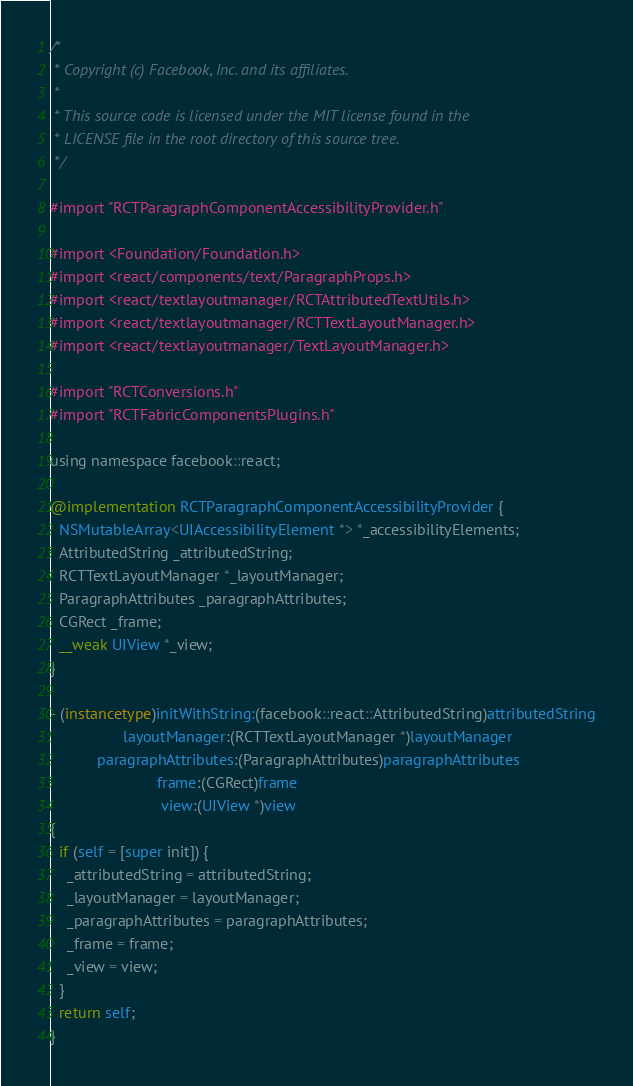Convert code to text. <code><loc_0><loc_0><loc_500><loc_500><_ObjectiveC_>/*
 * Copyright (c) Facebook, Inc. and its affiliates.
 *
 * This source code is licensed under the MIT license found in the
 * LICENSE file in the root directory of this source tree.
 */

#import "RCTParagraphComponentAccessibilityProvider.h"

#import <Foundation/Foundation.h>
#import <react/components/text/ParagraphProps.h>
#import <react/textlayoutmanager/RCTAttributedTextUtils.h>
#import <react/textlayoutmanager/RCTTextLayoutManager.h>
#import <react/textlayoutmanager/TextLayoutManager.h>

#import "RCTConversions.h"
#import "RCTFabricComponentsPlugins.h"

using namespace facebook::react;

@implementation RCTParagraphComponentAccessibilityProvider {
  NSMutableArray<UIAccessibilityElement *> *_accessibilityElements;
  AttributedString _attributedString;
  RCTTextLayoutManager *_layoutManager;
  ParagraphAttributes _paragraphAttributes;
  CGRect _frame;
  __weak UIView *_view;
}

- (instancetype)initWithString:(facebook::react::AttributedString)attributedString
                 layoutManager:(RCTTextLayoutManager *)layoutManager
           paragraphAttributes:(ParagraphAttributes)paragraphAttributes
                         frame:(CGRect)frame
                          view:(UIView *)view
{
  if (self = [super init]) {
    _attributedString = attributedString;
    _layoutManager = layoutManager;
    _paragraphAttributes = paragraphAttributes;
    _frame = frame;
    _view = view;
  }
  return self;
}
</code> 